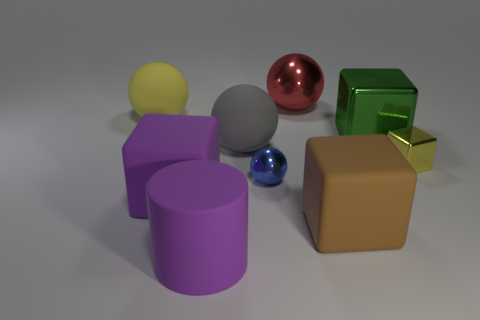Add 1 cyan blocks. How many objects exist? 10 Subtract all purple spheres. Subtract all green cylinders. How many spheres are left? 4 Subtract all cylinders. How many objects are left? 8 Add 3 yellow things. How many yellow things are left? 5 Add 3 big blue metallic spheres. How many big blue metallic spheres exist? 3 Subtract 1 yellow blocks. How many objects are left? 8 Subtract all big cyan cylinders. Subtract all tiny blue shiny things. How many objects are left? 8 